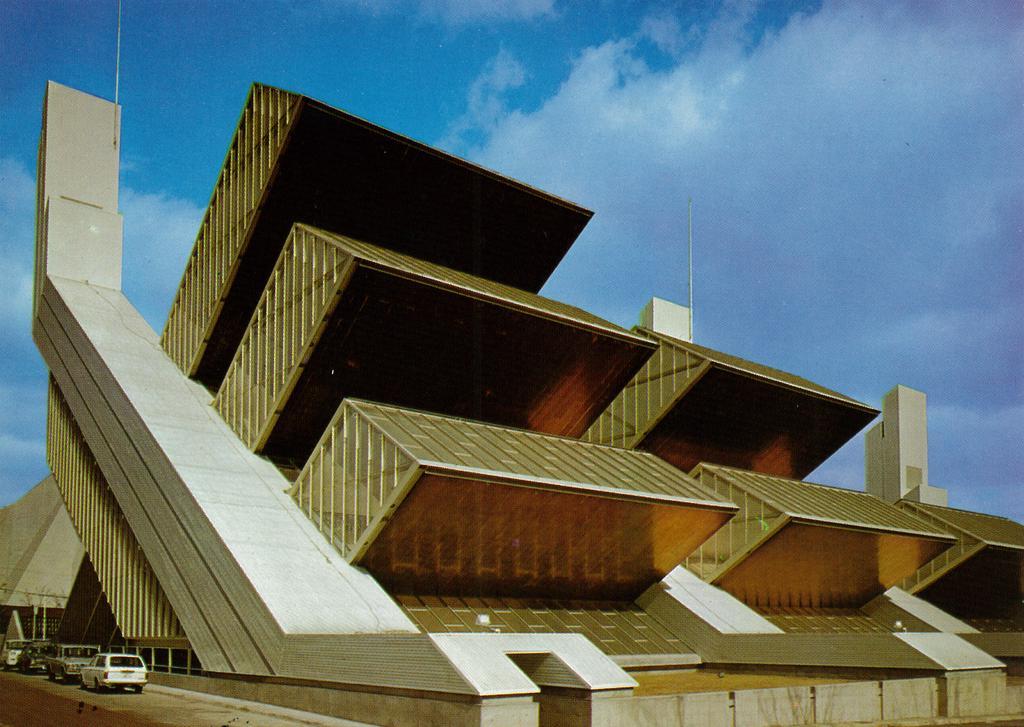How would you summarize this image in a sentence or two? In this image we can see a building. In the bottom left we can see few vehicles. At the top we can see the sky. 